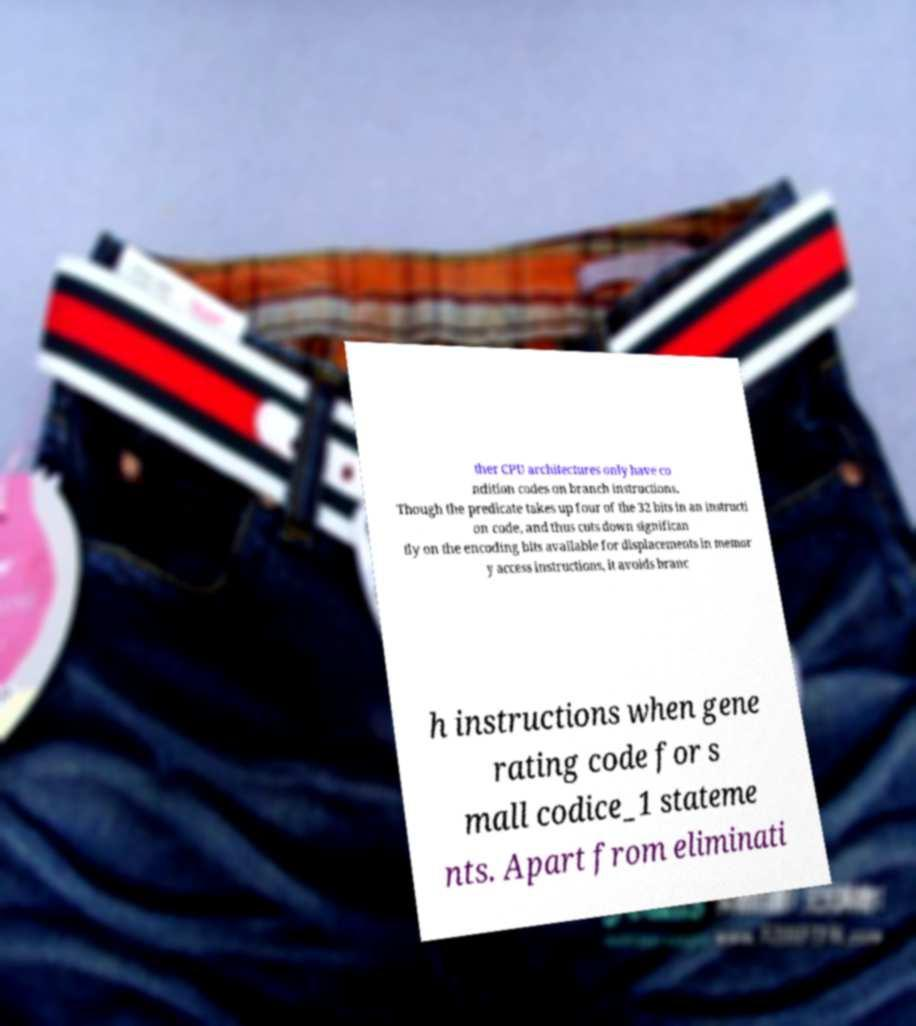Please identify and transcribe the text found in this image. ther CPU architectures only have co ndition codes on branch instructions. Though the predicate takes up four of the 32 bits in an instructi on code, and thus cuts down significan tly on the encoding bits available for displacements in memor y access instructions, it avoids branc h instructions when gene rating code for s mall codice_1 stateme nts. Apart from eliminati 